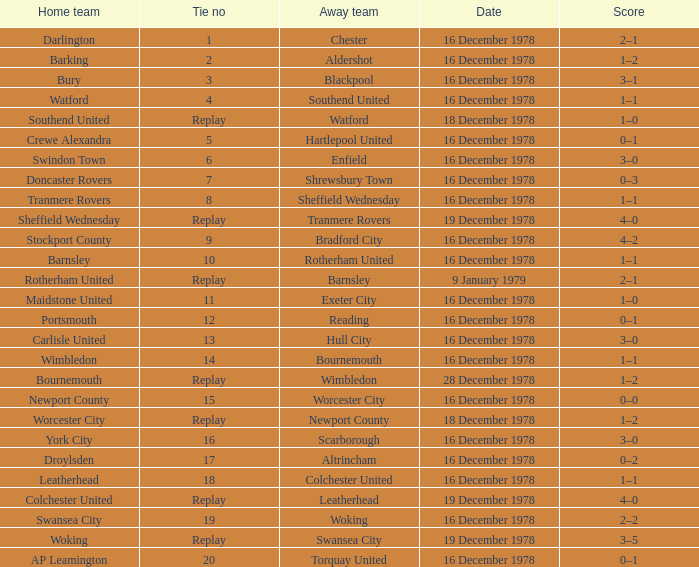What date had a tie no of replay, and an away team of watford? 18 December 1978. 